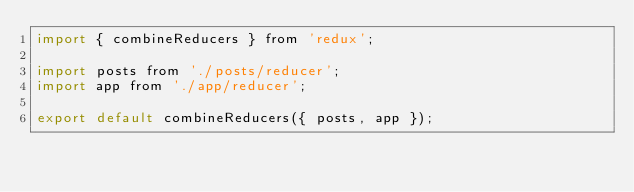<code> <loc_0><loc_0><loc_500><loc_500><_JavaScript_>import { combineReducers } from 'redux';

import posts from './posts/reducer';
import app from './app/reducer';

export default combineReducers({ posts, app });
</code> 